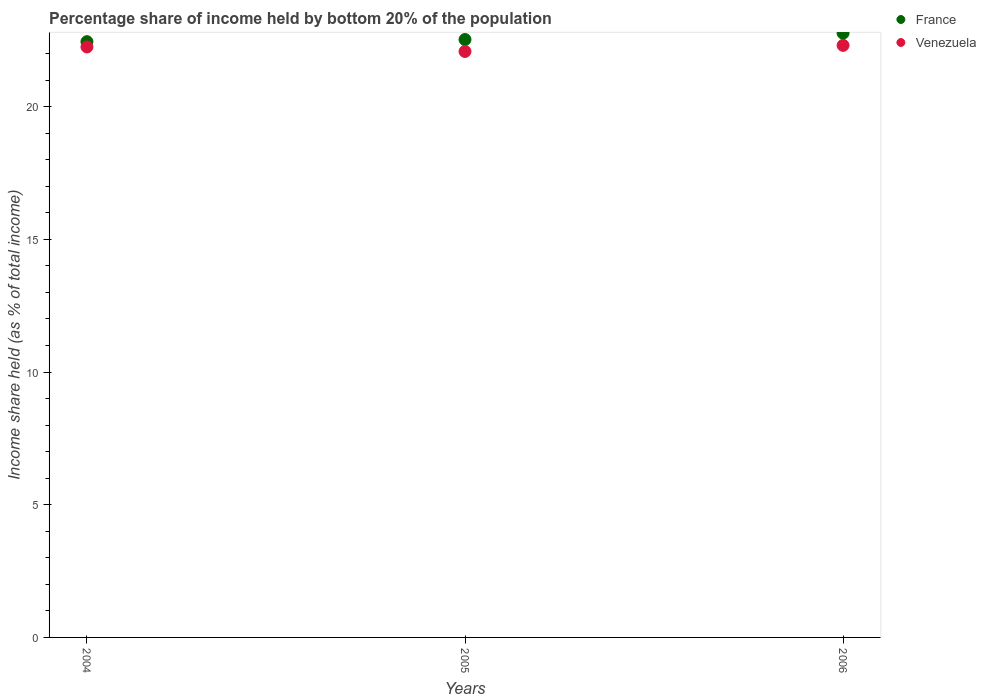How many different coloured dotlines are there?
Your response must be concise. 2. What is the share of income held by bottom 20% of the population in Venezuela in 2006?
Your response must be concise. 22.31. Across all years, what is the maximum share of income held by bottom 20% of the population in France?
Provide a short and direct response. 22.77. Across all years, what is the minimum share of income held by bottom 20% of the population in Venezuela?
Keep it short and to the point. 22.08. In which year was the share of income held by bottom 20% of the population in France maximum?
Offer a very short reply. 2006. In which year was the share of income held by bottom 20% of the population in France minimum?
Ensure brevity in your answer.  2004. What is the total share of income held by bottom 20% of the population in France in the graph?
Provide a succinct answer. 67.75. What is the difference between the share of income held by bottom 20% of the population in France in 2005 and that in 2006?
Your answer should be compact. -0.24. What is the difference between the share of income held by bottom 20% of the population in France in 2006 and the share of income held by bottom 20% of the population in Venezuela in 2004?
Offer a very short reply. 0.52. What is the average share of income held by bottom 20% of the population in France per year?
Your answer should be very brief. 22.58. In the year 2005, what is the difference between the share of income held by bottom 20% of the population in Venezuela and share of income held by bottom 20% of the population in France?
Provide a succinct answer. -0.45. What is the ratio of the share of income held by bottom 20% of the population in Venezuela in 2005 to that in 2006?
Keep it short and to the point. 0.99. Is the share of income held by bottom 20% of the population in Venezuela in 2004 less than that in 2005?
Offer a terse response. No. Is the difference between the share of income held by bottom 20% of the population in Venezuela in 2004 and 2005 greater than the difference between the share of income held by bottom 20% of the population in France in 2004 and 2005?
Offer a very short reply. Yes. What is the difference between the highest and the second highest share of income held by bottom 20% of the population in France?
Your answer should be very brief. 0.24. What is the difference between the highest and the lowest share of income held by bottom 20% of the population in France?
Offer a very short reply. 0.32. In how many years, is the share of income held by bottom 20% of the population in France greater than the average share of income held by bottom 20% of the population in France taken over all years?
Provide a short and direct response. 1. Is the share of income held by bottom 20% of the population in France strictly less than the share of income held by bottom 20% of the population in Venezuela over the years?
Your response must be concise. No. How many dotlines are there?
Offer a terse response. 2. How many years are there in the graph?
Ensure brevity in your answer.  3. Are the values on the major ticks of Y-axis written in scientific E-notation?
Keep it short and to the point. No. Where does the legend appear in the graph?
Offer a very short reply. Top right. What is the title of the graph?
Keep it short and to the point. Percentage share of income held by bottom 20% of the population. What is the label or title of the X-axis?
Offer a very short reply. Years. What is the label or title of the Y-axis?
Your response must be concise. Income share held (as % of total income). What is the Income share held (as % of total income) of France in 2004?
Offer a very short reply. 22.45. What is the Income share held (as % of total income) of Venezuela in 2004?
Make the answer very short. 22.25. What is the Income share held (as % of total income) of France in 2005?
Keep it short and to the point. 22.53. What is the Income share held (as % of total income) in Venezuela in 2005?
Offer a terse response. 22.08. What is the Income share held (as % of total income) of France in 2006?
Offer a terse response. 22.77. What is the Income share held (as % of total income) of Venezuela in 2006?
Offer a very short reply. 22.31. Across all years, what is the maximum Income share held (as % of total income) in France?
Offer a very short reply. 22.77. Across all years, what is the maximum Income share held (as % of total income) of Venezuela?
Give a very brief answer. 22.31. Across all years, what is the minimum Income share held (as % of total income) of France?
Provide a succinct answer. 22.45. Across all years, what is the minimum Income share held (as % of total income) in Venezuela?
Keep it short and to the point. 22.08. What is the total Income share held (as % of total income) of France in the graph?
Make the answer very short. 67.75. What is the total Income share held (as % of total income) in Venezuela in the graph?
Ensure brevity in your answer.  66.64. What is the difference between the Income share held (as % of total income) in France in 2004 and that in 2005?
Your answer should be compact. -0.08. What is the difference between the Income share held (as % of total income) of Venezuela in 2004 and that in 2005?
Offer a very short reply. 0.17. What is the difference between the Income share held (as % of total income) of France in 2004 and that in 2006?
Keep it short and to the point. -0.32. What is the difference between the Income share held (as % of total income) of Venezuela in 2004 and that in 2006?
Your answer should be compact. -0.06. What is the difference between the Income share held (as % of total income) of France in 2005 and that in 2006?
Offer a very short reply. -0.24. What is the difference between the Income share held (as % of total income) in Venezuela in 2005 and that in 2006?
Give a very brief answer. -0.23. What is the difference between the Income share held (as % of total income) of France in 2004 and the Income share held (as % of total income) of Venezuela in 2005?
Keep it short and to the point. 0.37. What is the difference between the Income share held (as % of total income) of France in 2004 and the Income share held (as % of total income) of Venezuela in 2006?
Your response must be concise. 0.14. What is the difference between the Income share held (as % of total income) of France in 2005 and the Income share held (as % of total income) of Venezuela in 2006?
Your answer should be compact. 0.22. What is the average Income share held (as % of total income) of France per year?
Provide a short and direct response. 22.58. What is the average Income share held (as % of total income) in Venezuela per year?
Your response must be concise. 22.21. In the year 2005, what is the difference between the Income share held (as % of total income) in France and Income share held (as % of total income) in Venezuela?
Provide a succinct answer. 0.45. In the year 2006, what is the difference between the Income share held (as % of total income) in France and Income share held (as % of total income) in Venezuela?
Make the answer very short. 0.46. What is the ratio of the Income share held (as % of total income) of Venezuela in 2004 to that in 2005?
Your answer should be compact. 1.01. What is the ratio of the Income share held (as % of total income) of France in 2004 to that in 2006?
Provide a short and direct response. 0.99. What is the ratio of the Income share held (as % of total income) of Venezuela in 2004 to that in 2006?
Keep it short and to the point. 1. What is the ratio of the Income share held (as % of total income) of Venezuela in 2005 to that in 2006?
Provide a succinct answer. 0.99. What is the difference between the highest and the second highest Income share held (as % of total income) in France?
Offer a terse response. 0.24. What is the difference between the highest and the second highest Income share held (as % of total income) in Venezuela?
Offer a very short reply. 0.06. What is the difference between the highest and the lowest Income share held (as % of total income) of France?
Your answer should be very brief. 0.32. What is the difference between the highest and the lowest Income share held (as % of total income) in Venezuela?
Your answer should be compact. 0.23. 